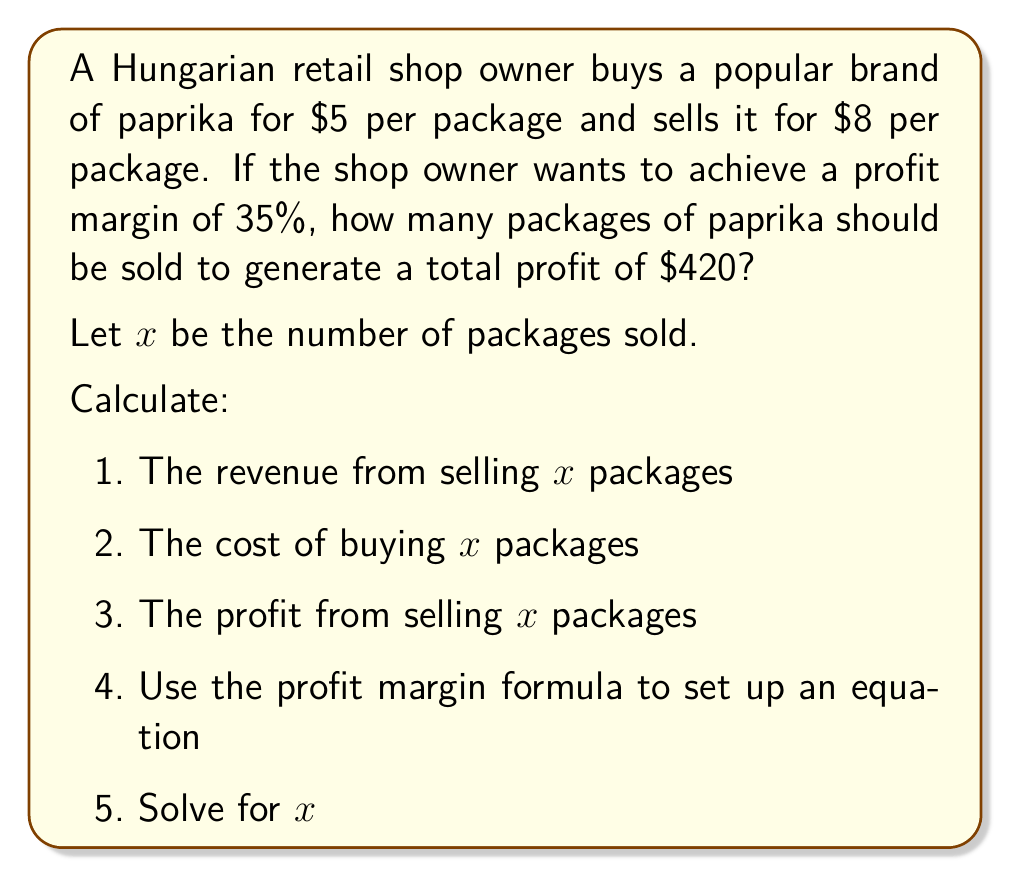Could you help me with this problem? Let's solve this step-by-step:

1) Revenue from selling $x$ packages:
   $R = 8x$

2) Cost of buying $x$ packages:
   $C = 5x$

3) Profit from selling $x$ packages:
   $P = R - C = 8x - 5x = 3x$

4) Profit margin formula:
   Profit Margin = $\frac{\text{Profit}}{\text{Revenue}}$

   We want this to equal 35% or 0.35:

   $0.35 = \frac{P}{R} = \frac{3x}{8x}$

5) Now, we know that the total profit should be $420:

   $3x = 420$

6) Solving for $x$:
   $x = 420 \div 3 = 140$

7) Let's verify the profit margin:
   Profit Margin = $\frac{P}{R} = \frac{3 \cdot 140}{8 \cdot 140} = \frac{420}{1120} = 0.375$ or 37.5%

The profit margin is slightly higher than 35% due to rounding. To get exactly 35%, we would need to sell a fractional number of packages, which isn't practical in this retail scenario.
Answer: 140 packages 